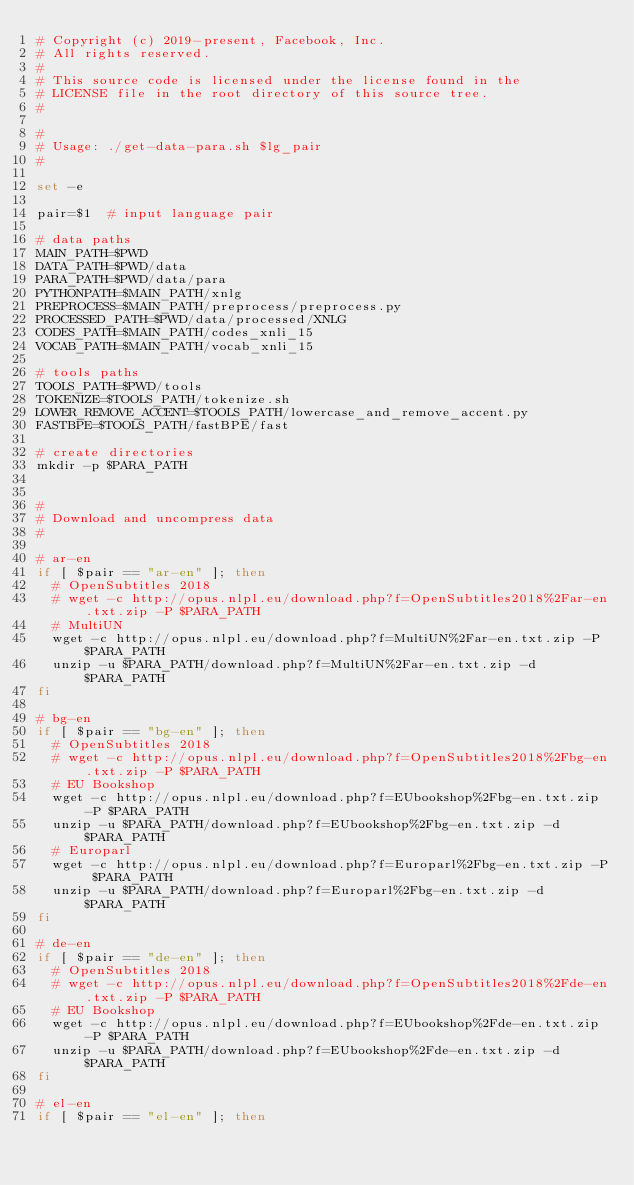<code> <loc_0><loc_0><loc_500><loc_500><_Bash_># Copyright (c) 2019-present, Facebook, Inc.
# All rights reserved.
#
# This source code is licensed under the license found in the
# LICENSE file in the root directory of this source tree.
#

#
# Usage: ./get-data-para.sh $lg_pair
#

set -e

pair=$1  # input language pair

# data paths
MAIN_PATH=$PWD
DATA_PATH=$PWD/data
PARA_PATH=$PWD/data/para
PYTHONPATH=$MAIN_PATH/xnlg
PREPROCESS=$MAIN_PATH/preprocess/preprocess.py
PROCESSED_PATH=$PWD/data/processed/XNLG
CODES_PATH=$MAIN_PATH/codes_xnli_15
VOCAB_PATH=$MAIN_PATH/vocab_xnli_15

# tools paths
TOOLS_PATH=$PWD/tools
TOKENIZE=$TOOLS_PATH/tokenize.sh
LOWER_REMOVE_ACCENT=$TOOLS_PATH/lowercase_and_remove_accent.py
FASTBPE=$TOOLS_PATH/fastBPE/fast

# create directories
mkdir -p $PARA_PATH


#
# Download and uncompress data
#

# ar-en
if [ $pair == "ar-en" ]; then
  # OpenSubtitles 2018
  # wget -c http://opus.nlpl.eu/download.php?f=OpenSubtitles2018%2Far-en.txt.zip -P $PARA_PATH
  # MultiUN
  wget -c http://opus.nlpl.eu/download.php?f=MultiUN%2Far-en.txt.zip -P $PARA_PATH
  unzip -u $PARA_PATH/download.php?f=MultiUN%2Far-en.txt.zip -d $PARA_PATH
fi

# bg-en
if [ $pair == "bg-en" ]; then
  # OpenSubtitles 2018
  # wget -c http://opus.nlpl.eu/download.php?f=OpenSubtitles2018%2Fbg-en.txt.zip -P $PARA_PATH
  # EU Bookshop
  wget -c http://opus.nlpl.eu/download.php?f=EUbookshop%2Fbg-en.txt.zip -P $PARA_PATH
  unzip -u $PARA_PATH/download.php?f=EUbookshop%2Fbg-en.txt.zip -d $PARA_PATH
  # Europarl
  wget -c http://opus.nlpl.eu/download.php?f=Europarl%2Fbg-en.txt.zip -P $PARA_PATH
  unzip -u $PARA_PATH/download.php?f=Europarl%2Fbg-en.txt.zip -d $PARA_PATH
fi

# de-en
if [ $pair == "de-en" ]; then
  # OpenSubtitles 2018
  # wget -c http://opus.nlpl.eu/download.php?f=OpenSubtitles2018%2Fde-en.txt.zip -P $PARA_PATH
  # EU Bookshop
  wget -c http://opus.nlpl.eu/download.php?f=EUbookshop%2Fde-en.txt.zip -P $PARA_PATH
  unzip -u $PARA_PATH/download.php?f=EUbookshop%2Fde-en.txt.zip -d $PARA_PATH
fi

# el-en
if [ $pair == "el-en" ]; then</code> 